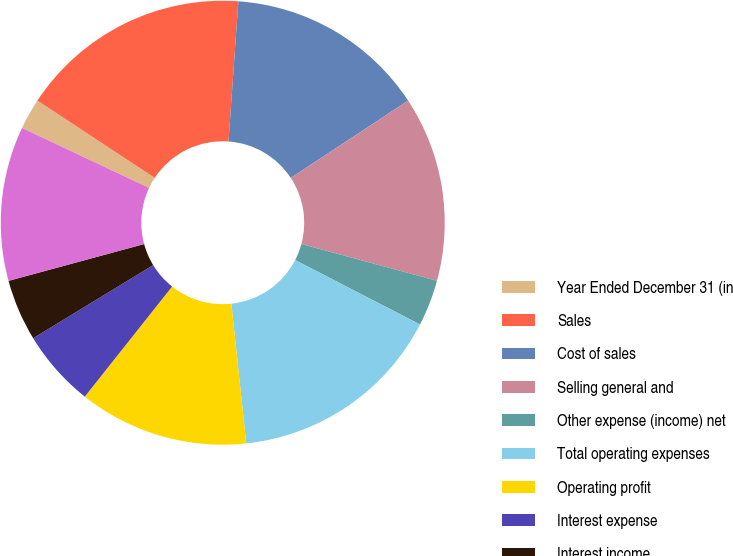Convert chart. <chart><loc_0><loc_0><loc_500><loc_500><pie_chart><fcel>Year Ended December 31 (in<fcel>Sales<fcel>Cost of sales<fcel>Selling general and<fcel>Other expense (income) net<fcel>Total operating expenses<fcel>Operating profit<fcel>Interest expense<fcel>Interest income<fcel>Earnings before income taxes<nl><fcel>2.25%<fcel>16.85%<fcel>14.61%<fcel>13.48%<fcel>3.37%<fcel>15.73%<fcel>12.36%<fcel>5.62%<fcel>4.49%<fcel>11.24%<nl></chart> 